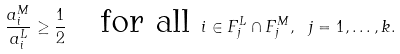Convert formula to latex. <formula><loc_0><loc_0><loc_500><loc_500>\frac { a ^ { M } _ { i } } { a ^ { L } _ { i } } \geq \frac { 1 } { 2 } \quad \text {for all} \ i \in F ^ { L } _ { j } \cap F ^ { M } _ { j } , \ j = 1 , \dots , k .</formula> 